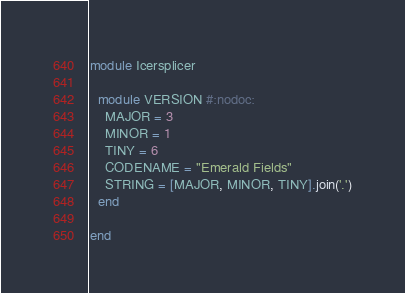Convert code to text. <code><loc_0><loc_0><loc_500><loc_500><_Crystal_>
module Icersplicer

  module VERSION #:nodoc:
    MAJOR = 3
    MINOR = 1
    TINY = 6
    CODENAME = "Emerald Fields"
    STRING = [MAJOR, MINOR, TINY].join('.')
  end

end
</code> 